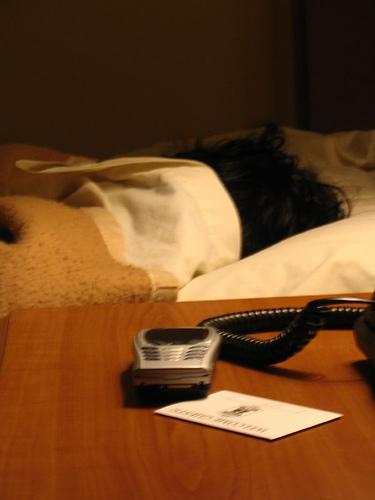Is the person sleeping?
Answer briefly. Yes. Is this hotel room?
Short answer required. Yes. Is this a modern mobile phone?
Quick response, please. No. 